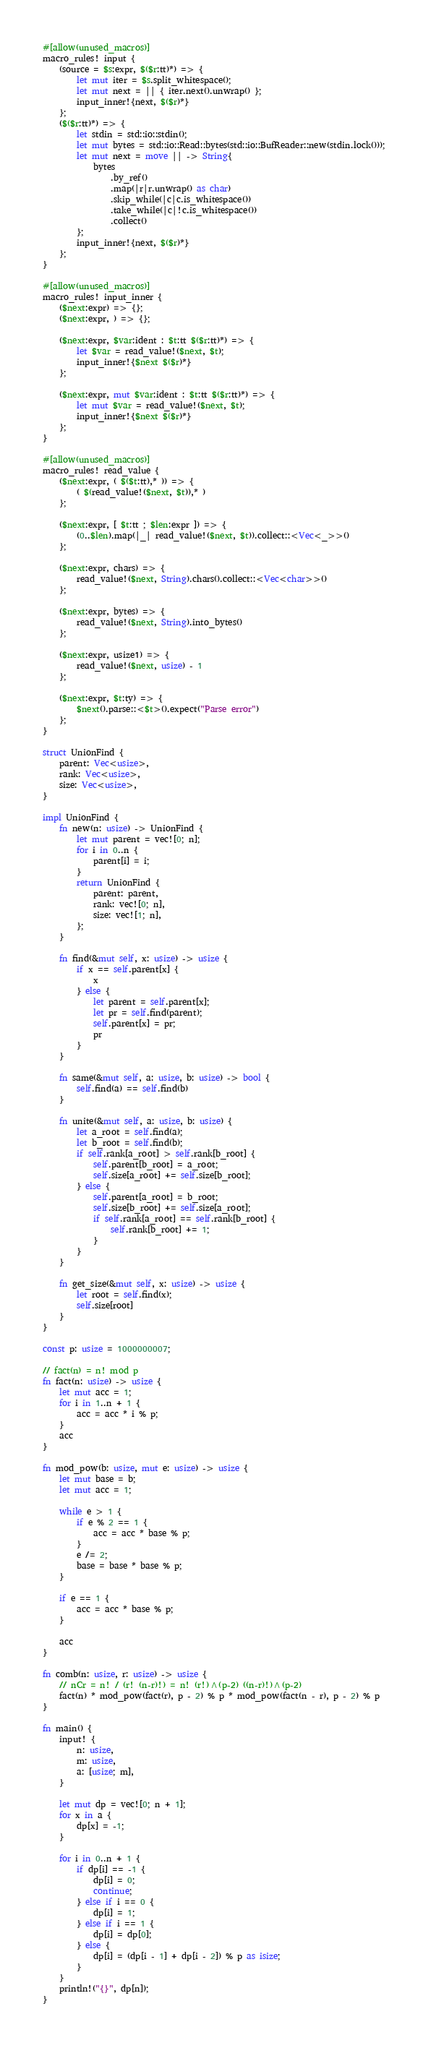Convert code to text. <code><loc_0><loc_0><loc_500><loc_500><_Rust_>#[allow(unused_macros)]
macro_rules! input {
    (source = $s:expr, $($r:tt)*) => {
        let mut iter = $s.split_whitespace();
        let mut next = || { iter.next().unwrap() };
        input_inner!{next, $($r)*}
    };
    ($($r:tt)*) => {
        let stdin = std::io::stdin();
        let mut bytes = std::io::Read::bytes(std::io::BufReader::new(stdin.lock()));
        let mut next = move || -> String{
            bytes
                .by_ref()
                .map(|r|r.unwrap() as char)
                .skip_while(|c|c.is_whitespace())
                .take_while(|c|!c.is_whitespace())
                .collect()
        };
        input_inner!{next, $($r)*}
    };
}

#[allow(unused_macros)]
macro_rules! input_inner {
    ($next:expr) => {};
    ($next:expr, ) => {};

    ($next:expr, $var:ident : $t:tt $($r:tt)*) => {
        let $var = read_value!($next, $t);
        input_inner!{$next $($r)*}
    };

    ($next:expr, mut $var:ident : $t:tt $($r:tt)*) => {
        let mut $var = read_value!($next, $t);
        input_inner!{$next $($r)*}
    };
}

#[allow(unused_macros)]
macro_rules! read_value {
    ($next:expr, ( $($t:tt),* )) => {
        ( $(read_value!($next, $t)),* )
    };

    ($next:expr, [ $t:tt ; $len:expr ]) => {
        (0..$len).map(|_| read_value!($next, $t)).collect::<Vec<_>>()
    };

    ($next:expr, chars) => {
        read_value!($next, String).chars().collect::<Vec<char>>()
    };

    ($next:expr, bytes) => {
        read_value!($next, String).into_bytes()
    };

    ($next:expr, usize1) => {
        read_value!($next, usize) - 1
    };

    ($next:expr, $t:ty) => {
        $next().parse::<$t>().expect("Parse error")
    };
}

struct UnionFind {
    parent: Vec<usize>,
    rank: Vec<usize>,
    size: Vec<usize>,
}

impl UnionFind {
    fn new(n: usize) -> UnionFind {
        let mut parent = vec![0; n];
        for i in 0..n {
            parent[i] = i;
        }
        return UnionFind {
            parent: parent,
            rank: vec![0; n],
            size: vec![1; n],
        };
    }

    fn find(&mut self, x: usize) -> usize {
        if x == self.parent[x] {
            x
        } else {
            let parent = self.parent[x];
            let pr = self.find(parent);
            self.parent[x] = pr;
            pr
        }
    }

    fn same(&mut self, a: usize, b: usize) -> bool {
        self.find(a) == self.find(b)
    }

    fn unite(&mut self, a: usize, b: usize) {
        let a_root = self.find(a);
        let b_root = self.find(b);
        if self.rank[a_root] > self.rank[b_root] {
            self.parent[b_root] = a_root;
            self.size[a_root] += self.size[b_root];
        } else {
            self.parent[a_root] = b_root;
            self.size[b_root] += self.size[a_root];
            if self.rank[a_root] == self.rank[b_root] {
                self.rank[b_root] += 1;
            }
        }
    }

    fn get_size(&mut self, x: usize) -> usize {
        let root = self.find(x);
        self.size[root]
    }
}

const p: usize = 1000000007;

// fact(n) = n! mod p
fn fact(n: usize) -> usize {
    let mut acc = 1;
    for i in 1..n + 1 {
        acc = acc * i % p;
    }
    acc
}

fn mod_pow(b: usize, mut e: usize) -> usize {
    let mut base = b;
    let mut acc = 1;

    while e > 1 {
        if e % 2 == 1 {
            acc = acc * base % p;
        }
        e /= 2;
        base = base * base % p;
    }

    if e == 1 {
        acc = acc * base % p;
    }

    acc
}

fn comb(n: usize, r: usize) -> usize {
    // nCr = n! / (r! (n-r)!) = n! (r!)^(p-2) ((n-r)!)^(p-2)
    fact(n) * mod_pow(fact(r), p - 2) % p * mod_pow(fact(n - r), p - 2) % p
}

fn main() {
    input! {
        n: usize,
        m: usize,
        a: [usize; m],
    }

    let mut dp = vec![0; n + 1];
    for x in a {
        dp[x] = -1;
    }

    for i in 0..n + 1 {
        if dp[i] == -1 {
            dp[i] = 0;
            continue;
        } else if i == 0 {
            dp[i] = 1;
        } else if i == 1 {
            dp[i] = dp[0];
        } else {
            dp[i] = (dp[i - 1] + dp[i - 2]) % p as isize;
        }
    }
    println!("{}", dp[n]);
}
</code> 